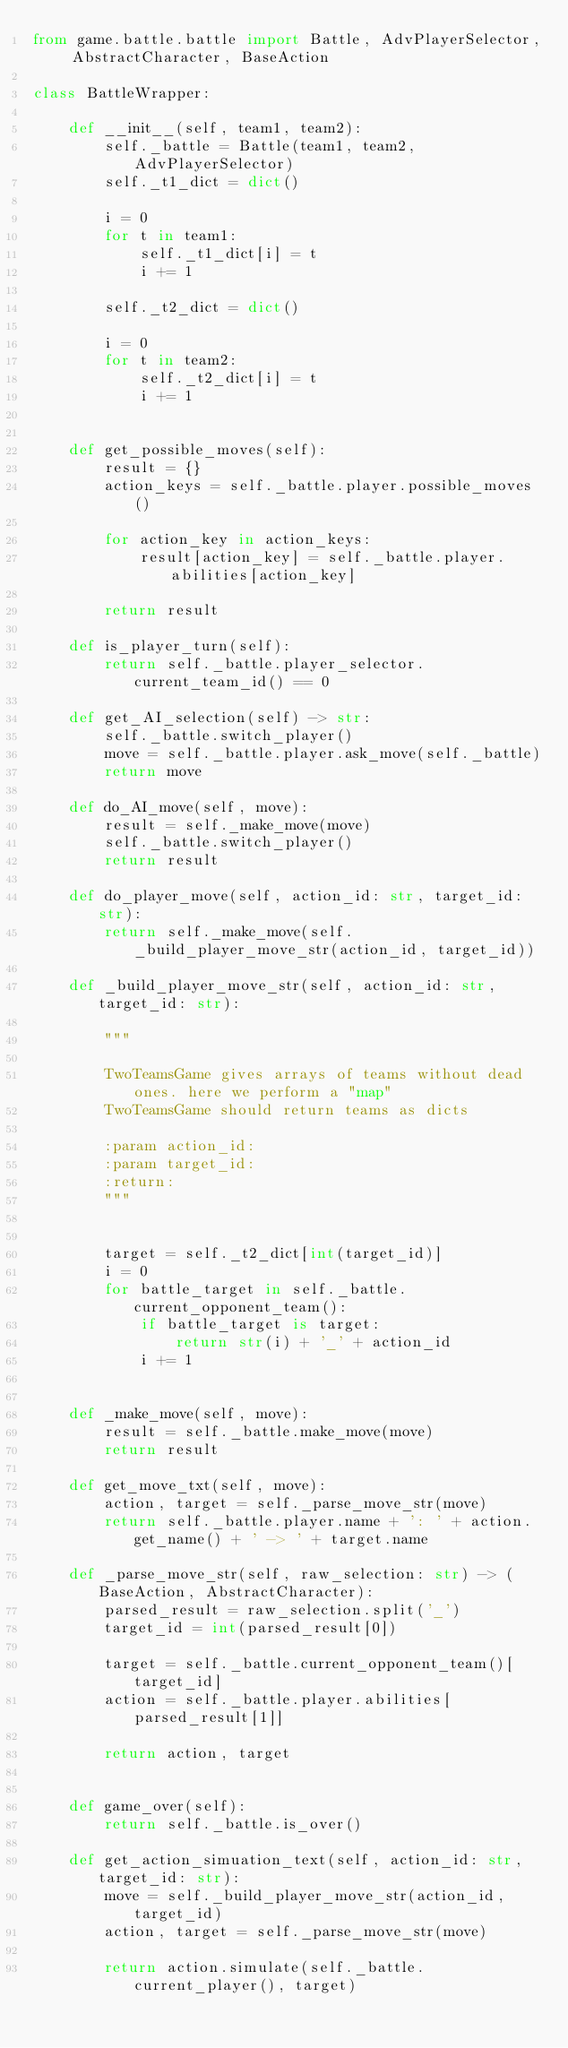<code> <loc_0><loc_0><loc_500><loc_500><_Python_>from game.battle.battle import Battle, AdvPlayerSelector, AbstractCharacter, BaseAction

class BattleWrapper:

    def __init__(self, team1, team2):
        self._battle = Battle(team1, team2, AdvPlayerSelector)
        self._t1_dict = dict()

        i = 0
        for t in team1:
            self._t1_dict[i] = t
            i += 1

        self._t2_dict = dict()

        i = 0
        for t in team2:
            self._t2_dict[i] = t
            i += 1


    def get_possible_moves(self):
        result = {}
        action_keys = self._battle.player.possible_moves()

        for action_key in action_keys:
            result[action_key] = self._battle.player.abilities[action_key]

        return result

    def is_player_turn(self):
        return self._battle.player_selector.current_team_id() == 0

    def get_AI_selection(self) -> str:
        self._battle.switch_player()
        move = self._battle.player.ask_move(self._battle)
        return move

    def do_AI_move(self, move):
        result = self._make_move(move)
        self._battle.switch_player()
        return result

    def do_player_move(self, action_id: str, target_id: str):
        return self._make_move(self._build_player_move_str(action_id, target_id))

    def _build_player_move_str(self, action_id: str, target_id: str):

        """

        TwoTeamsGame gives arrays of teams without dead ones. here we perform a "map"
        TwoTeamsGame should return teams as dicts

        :param action_id:
        :param target_id:
        :return:
        """


        target = self._t2_dict[int(target_id)]
        i = 0
        for battle_target in self._battle.current_opponent_team():
            if battle_target is target:
                return str(i) + '_' + action_id
            i += 1


    def _make_move(self, move):
        result = self._battle.make_move(move)
        return result

    def get_move_txt(self, move):
        action, target = self._parse_move_str(move)
        return self._battle.player.name + ': ' + action.get_name() + ' -> ' + target.name

    def _parse_move_str(self, raw_selection: str) -> (BaseAction, AbstractCharacter):
        parsed_result = raw_selection.split('_')
        target_id = int(parsed_result[0])

        target = self._battle.current_opponent_team()[target_id]
        action = self._battle.player.abilities[parsed_result[1]]

        return action, target


    def game_over(self):
        return self._battle.is_over()

    def get_action_simuation_text(self, action_id: str, target_id: str):
        move = self._build_player_move_str(action_id, target_id)
        action, target = self._parse_move_str(move)

        return action.simulate(self._battle.current_player(), target)
</code> 